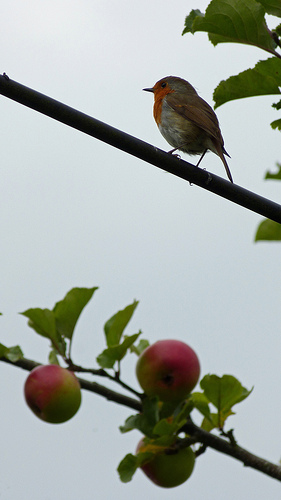How many apples are there? 3 